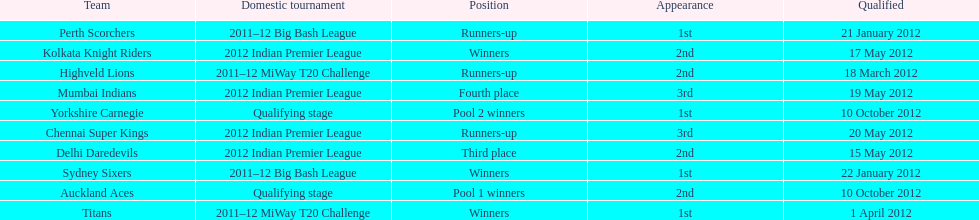The auckland aces and yorkshire carnegie qualified on what date? 10 October 2012. 